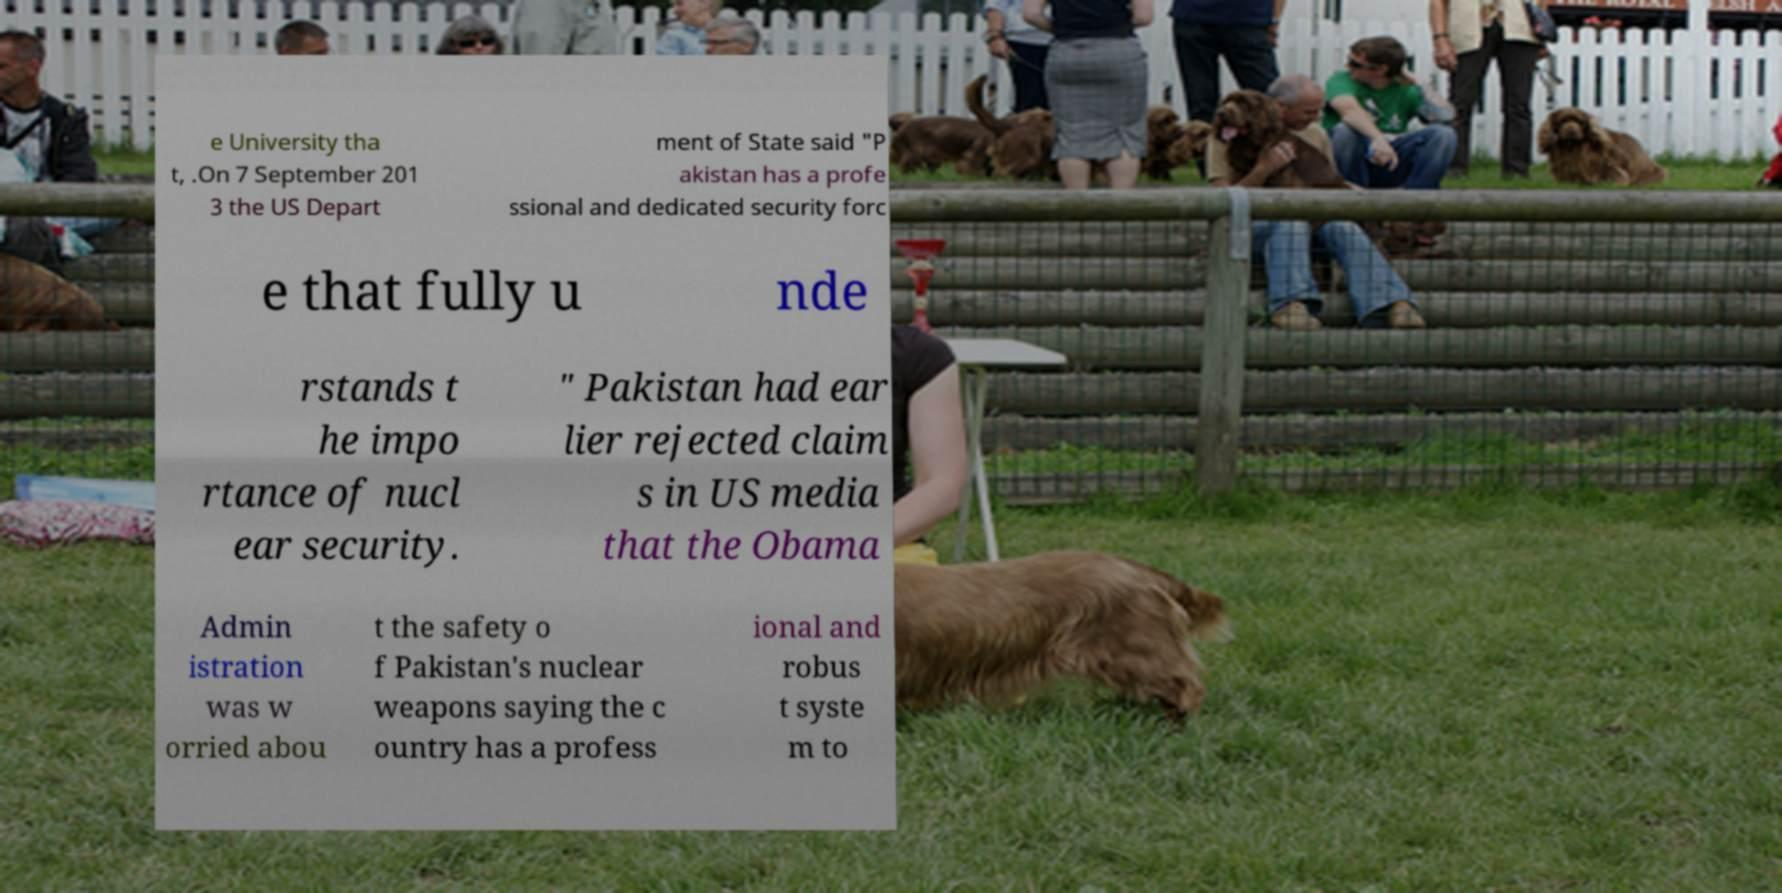For documentation purposes, I need the text within this image transcribed. Could you provide that? e University tha t, .On 7 September 201 3 the US Depart ment of State said "P akistan has a profe ssional and dedicated security forc e that fully u nde rstands t he impo rtance of nucl ear security. " Pakistan had ear lier rejected claim s in US media that the Obama Admin istration was w orried abou t the safety o f Pakistan's nuclear weapons saying the c ountry has a profess ional and robus t syste m to 